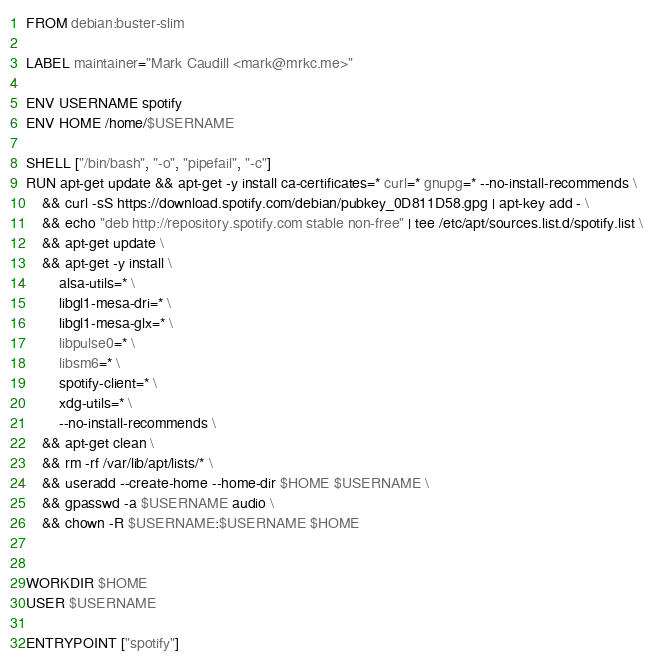<code> <loc_0><loc_0><loc_500><loc_500><_Dockerfile_>FROM debian:buster-slim

LABEL maintainer="Mark Caudill <mark@mrkc.me>"

ENV USERNAME spotify
ENV HOME /home/$USERNAME

SHELL ["/bin/bash", "-o", "pipefail", "-c"]
RUN apt-get update && apt-get -y install ca-certificates=* curl=* gnupg=* --no-install-recommends \
	&& curl -sS https://download.spotify.com/debian/pubkey_0D811D58.gpg | apt-key add - \
	&& echo "deb http://repository.spotify.com stable non-free" | tee /etc/apt/sources.list.d/spotify.list \
	&& apt-get update \
	&& apt-get -y install \
		alsa-utils=* \
		libgl1-mesa-dri=* \
		libgl1-mesa-glx=* \
		libpulse0=* \
		libsm6=* \
		spotify-client=* \
		xdg-utils=* \
		--no-install-recommends \
	&& apt-get clean \
	&& rm -rf /var/lib/apt/lists/* \
	&& useradd --create-home --home-dir $HOME $USERNAME \
	&& gpasswd -a $USERNAME audio \
	&& chown -R $USERNAME:$USERNAME $HOME


WORKDIR $HOME
USER $USERNAME

ENTRYPOINT ["spotify"]

</code> 